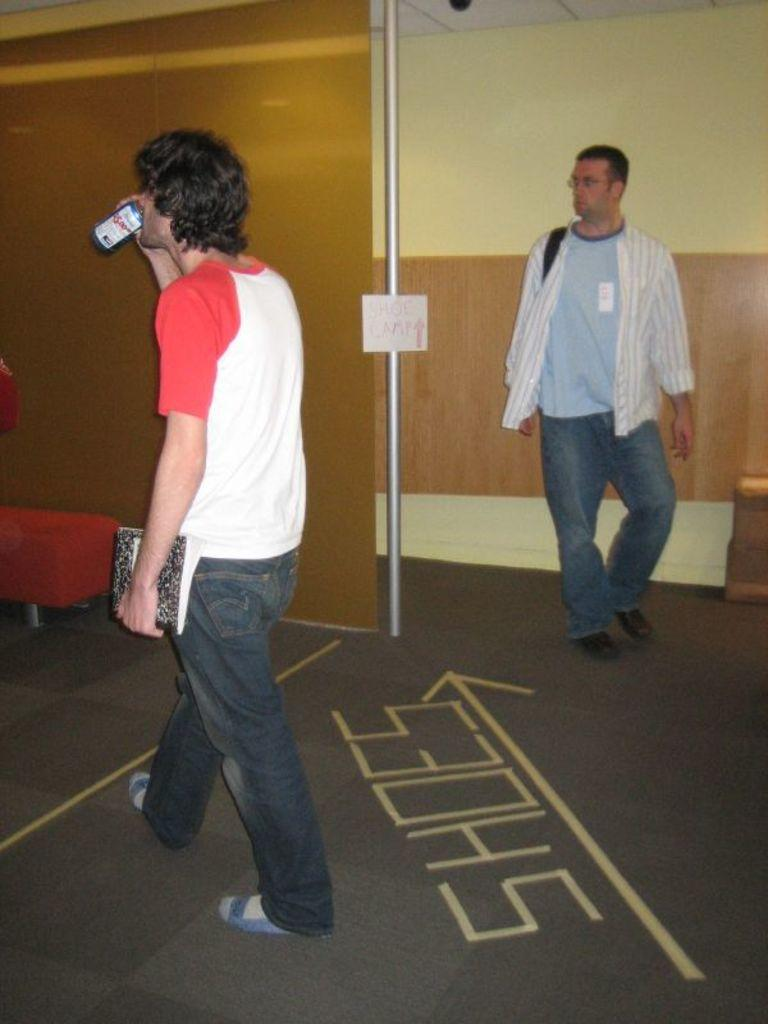What is the person in the image holding? The person is holding a bottle and a book in the image. What is the person doing in the image? The person is walking on the road. Can you describe the other person in the image? There is another person on the right side of the image. What can be seen in the middle of the image? There is a wall and a stand in the middle of the image. Can you see any ghosts helping the person in the image? There are no ghosts present in the image, and therefore no such assistance can be observed. 